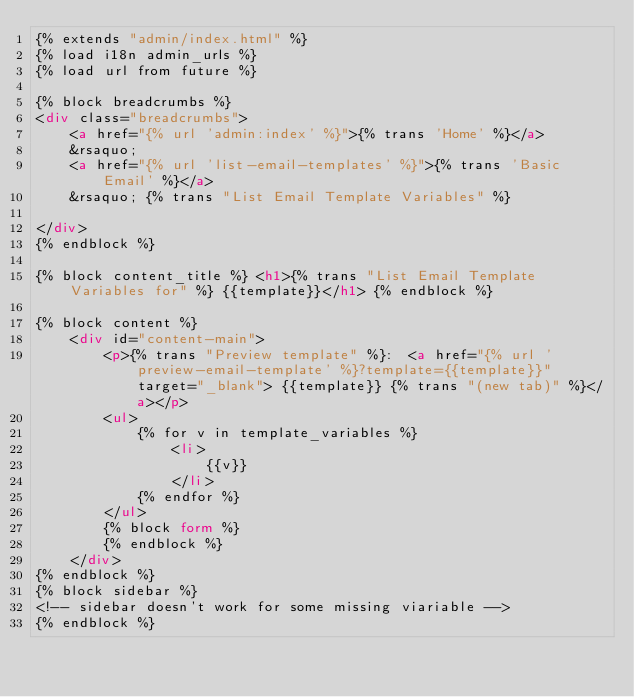<code> <loc_0><loc_0><loc_500><loc_500><_HTML_>{% extends "admin/index.html" %}
{% load i18n admin_urls %}
{% load url from future %}

{% block breadcrumbs %}
<div class="breadcrumbs">
    <a href="{% url 'admin:index' %}">{% trans 'Home' %}</a>
    &rsaquo;
    <a href="{% url 'list-email-templates' %}">{% trans 'Basic Email' %}</a>
    &rsaquo; {% trans "List Email Template Variables" %}

</div>
{% endblock %}

{% block content_title %} <h1>{% trans "List Email Template Variables for" %} {{template}}</h1> {% endblock %}

{% block content %}
    <div id="content-main">
        <p>{% trans "Preview template" %}:  <a href="{% url 'preview-email-template' %}?template={{template}}" target="_blank"> {{template}} {% trans "(new tab)" %}</a></p>
        <ul>
            {% for v in template_variables %}
                <li>
                    {{v}}
                </li>
            {% endfor %}
        </ul>
        {% block form %}
        {% endblock %}
    </div>
{% endblock %}
{% block sidebar %}
<!-- sidebar doesn't work for some missing viariable -->
{% endblock %}</code> 